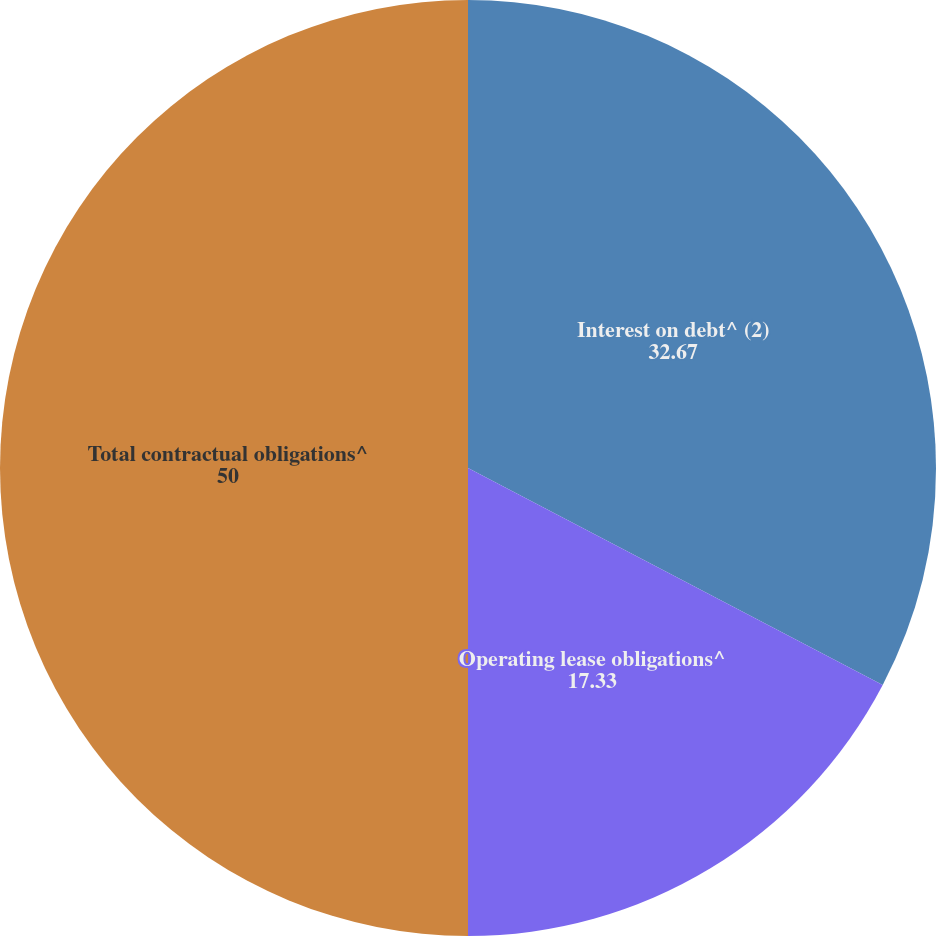<chart> <loc_0><loc_0><loc_500><loc_500><pie_chart><fcel>Interest on debt^ (2)<fcel>Operating lease obligations^<fcel>Total contractual obligations^<nl><fcel>32.67%<fcel>17.33%<fcel>50.0%<nl></chart> 